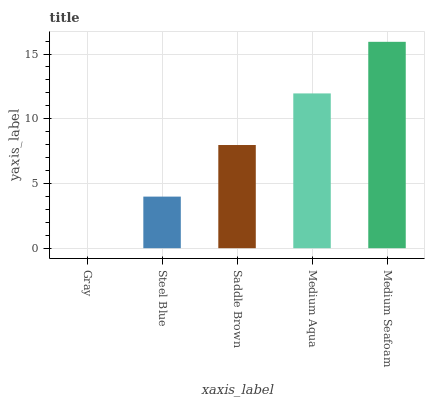Is Gray the minimum?
Answer yes or no. Yes. Is Medium Seafoam the maximum?
Answer yes or no. Yes. Is Steel Blue the minimum?
Answer yes or no. No. Is Steel Blue the maximum?
Answer yes or no. No. Is Steel Blue greater than Gray?
Answer yes or no. Yes. Is Gray less than Steel Blue?
Answer yes or no. Yes. Is Gray greater than Steel Blue?
Answer yes or no. No. Is Steel Blue less than Gray?
Answer yes or no. No. Is Saddle Brown the high median?
Answer yes or no. Yes. Is Saddle Brown the low median?
Answer yes or no. Yes. Is Steel Blue the high median?
Answer yes or no. No. Is Medium Aqua the low median?
Answer yes or no. No. 